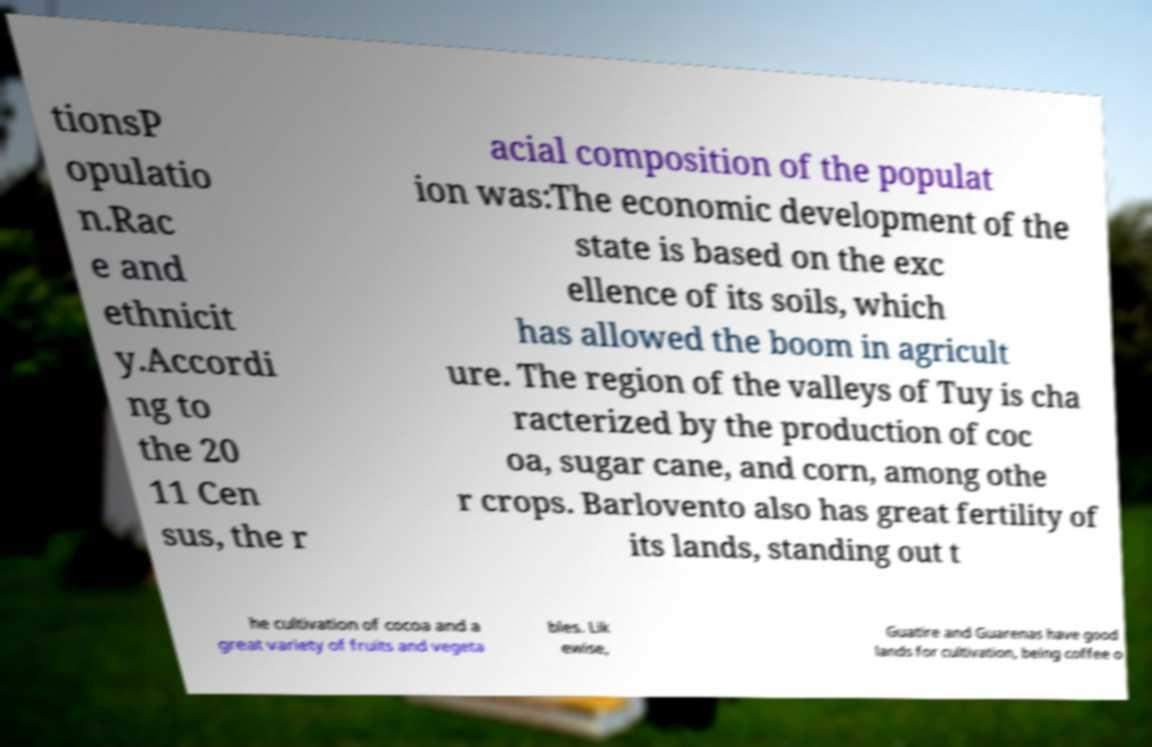Please identify and transcribe the text found in this image. tionsP opulatio n.Rac e and ethnicit y.Accordi ng to the 20 11 Cen sus, the r acial composition of the populat ion was:The economic development of the state is based on the exc ellence of its soils, which has allowed the boom in agricult ure. The region of the valleys of Tuy is cha racterized by the production of coc oa, sugar cane, and corn, among othe r crops. Barlovento also has great fertility of its lands, standing out t he cultivation of cocoa and a great variety of fruits and vegeta bles. Lik ewise, Guatire and Guarenas have good lands for cultivation, being coffee o 